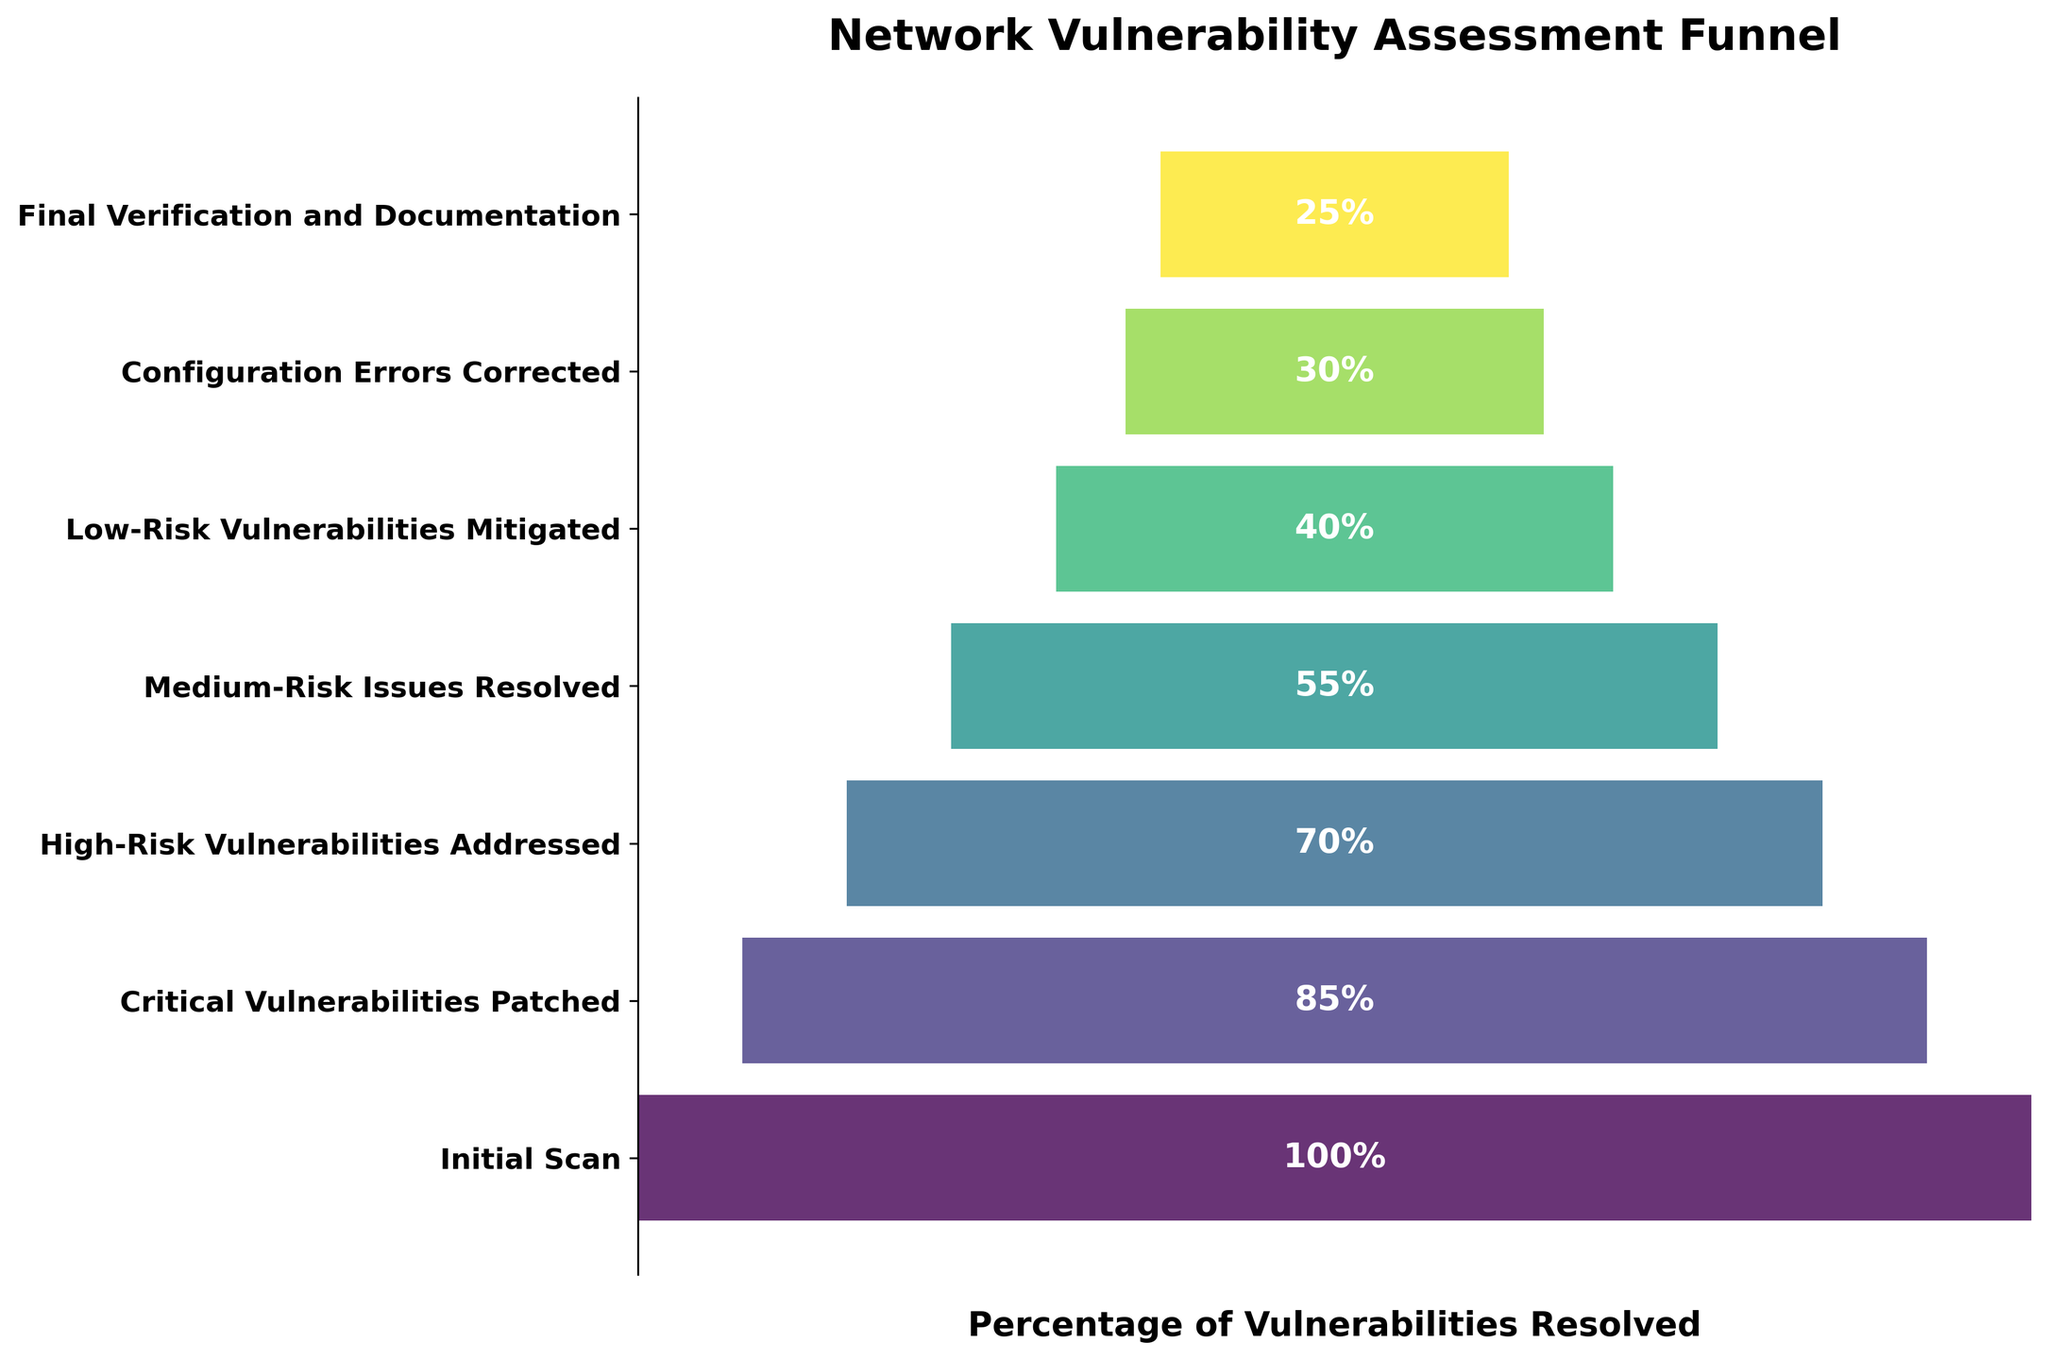What is the title of the chart? The title of the chart is displayed prominently at the top. It reads "Network Vulnerability Assessment Funnel."
Answer: Network Vulnerability Assessment Funnel How many steps are displayed in the funnel chart? The funnel chart has 7 steps displayed as horizontal bars.
Answer: 7 Which step has the highest percentage of vulnerabilities resolved? The step with the highest percentage of vulnerabilities resolved is the first bar at 100%, labeled "Initial Scan."
Answer: Initial Scan What is the percentage of vulnerabilities resolved at the "Medium-Risk Issues Resolved" step? The percentage for "Medium-Risk Issues Resolved" is shown within the corresponding horizontal bar, which is 55%.
Answer: 55% Between which two consecutive steps is the largest decrease in vulnerabilities resolved observed? The largest decrease can be identified by looking at the difference between consecutive bars. The drop from "Initial Scan" (100%) to "Critical Vulnerabilities Patched" (85%) is 15%, which is the largest observed.
Answer: Initial Scan to Critical Vulnerabilities Patched What is the decrease in percentage of vulnerabilities resolved from "High-Risk Vulnerabilities Addressed" to "Final Verification and Documentation"? Calculate the difference between percentages for these two steps: 70% (High-Risk Vulnerabilities Addressed) - 25% (Final Verification and Documentation) = 45%.
Answer: 45% What percentage of vulnerabilities remain unresolved after the "Configuration Errors Corrected" step? To find the unresolved percentage, subtract the resolved percentage at this step from 100%. 100% - 30% = 70% remain unresolved after this step.
Answer: 70% What is the average percentage of vulnerabilities resolved for the steps "Critical Vulnerabilities Patched," "High-Risk Vulnerabilities Addressed," and "Medium-Risk Issues Resolved"? The average is calculated by summing the percentages for these steps and dividing by the number of steps: (85% + 70% + 55%) / 3 = 210% / 3 = 70%.
Answer: 70% Does the color of the bars change uniformly across the steps? The colors of the bars vary and appear to follow a gradient, moving from a lighter to a darker shade, indicating a uniform color scheme progression.
Answer: Yes What is the visual shape of the funnel chart? The funnel chart takes the shape of an actual funnel, with wider bars at the top gradually narrowing down to smaller bars at the bottom.
Answer: Funnel 